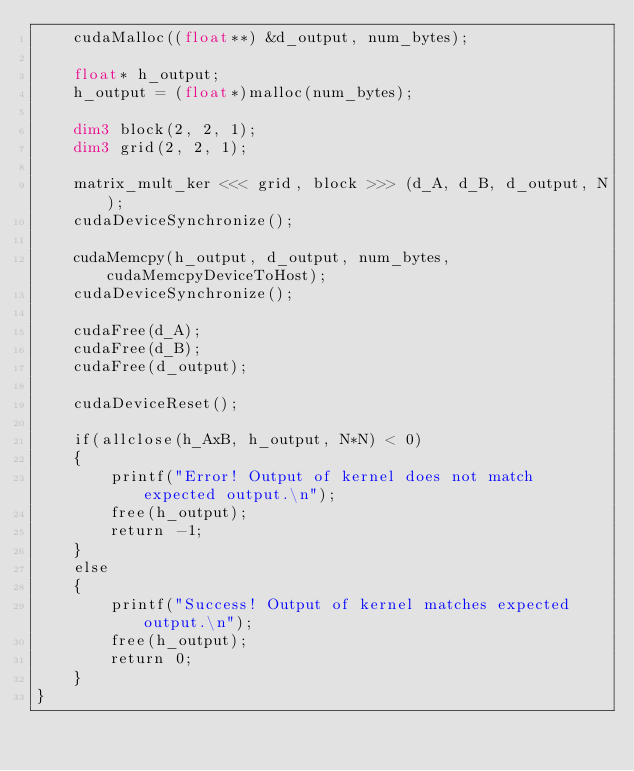<code> <loc_0><loc_0><loc_500><loc_500><_Cuda_>    cudaMalloc((float**) &d_output, num_bytes);

    float* h_output;
    h_output = (float*)malloc(num_bytes);

    dim3 block(2, 2, 1);
    dim3 grid(2, 2, 1);

    matrix_mult_ker <<< grid, block >>> (d_A, d_B, d_output, N);
    cudaDeviceSynchronize();

    cudaMemcpy(h_output, d_output, num_bytes, cudaMemcpyDeviceToHost);
    cudaDeviceSynchronize();

    cudaFree(d_A);
    cudaFree(d_B);
    cudaFree(d_output);

    cudaDeviceReset();

    if(allclose(h_AxB, h_output, N*N) < 0)
    {
        printf("Error! Output of kernel does not match expected output.\n");
        free(h_output);
        return -1;
    }
    else
    {
        printf("Success! Output of kernel matches expected output.\n");
        free(h_output);
        return 0;
    }
}    

</code> 